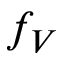<formula> <loc_0><loc_0><loc_500><loc_500>f _ { V }</formula> 